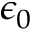Convert formula to latex. <formula><loc_0><loc_0><loc_500><loc_500>\epsilon _ { 0 }</formula> 